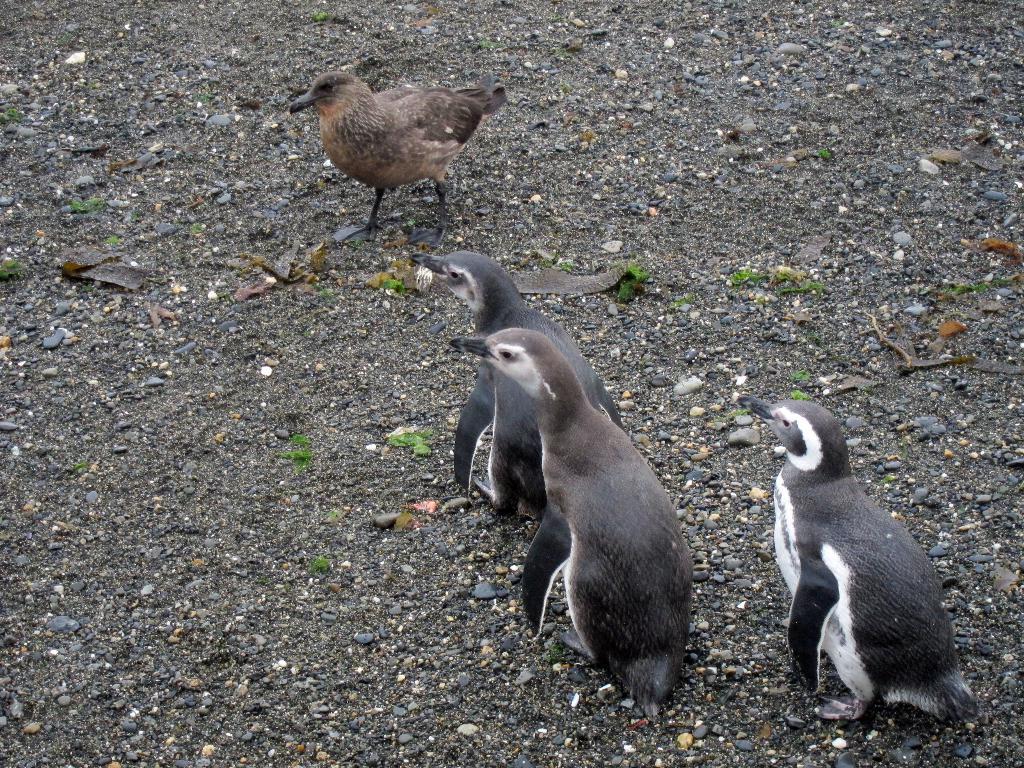In one or two sentences, can you explain what this image depicts? In this image I can see penguins and a bird. 